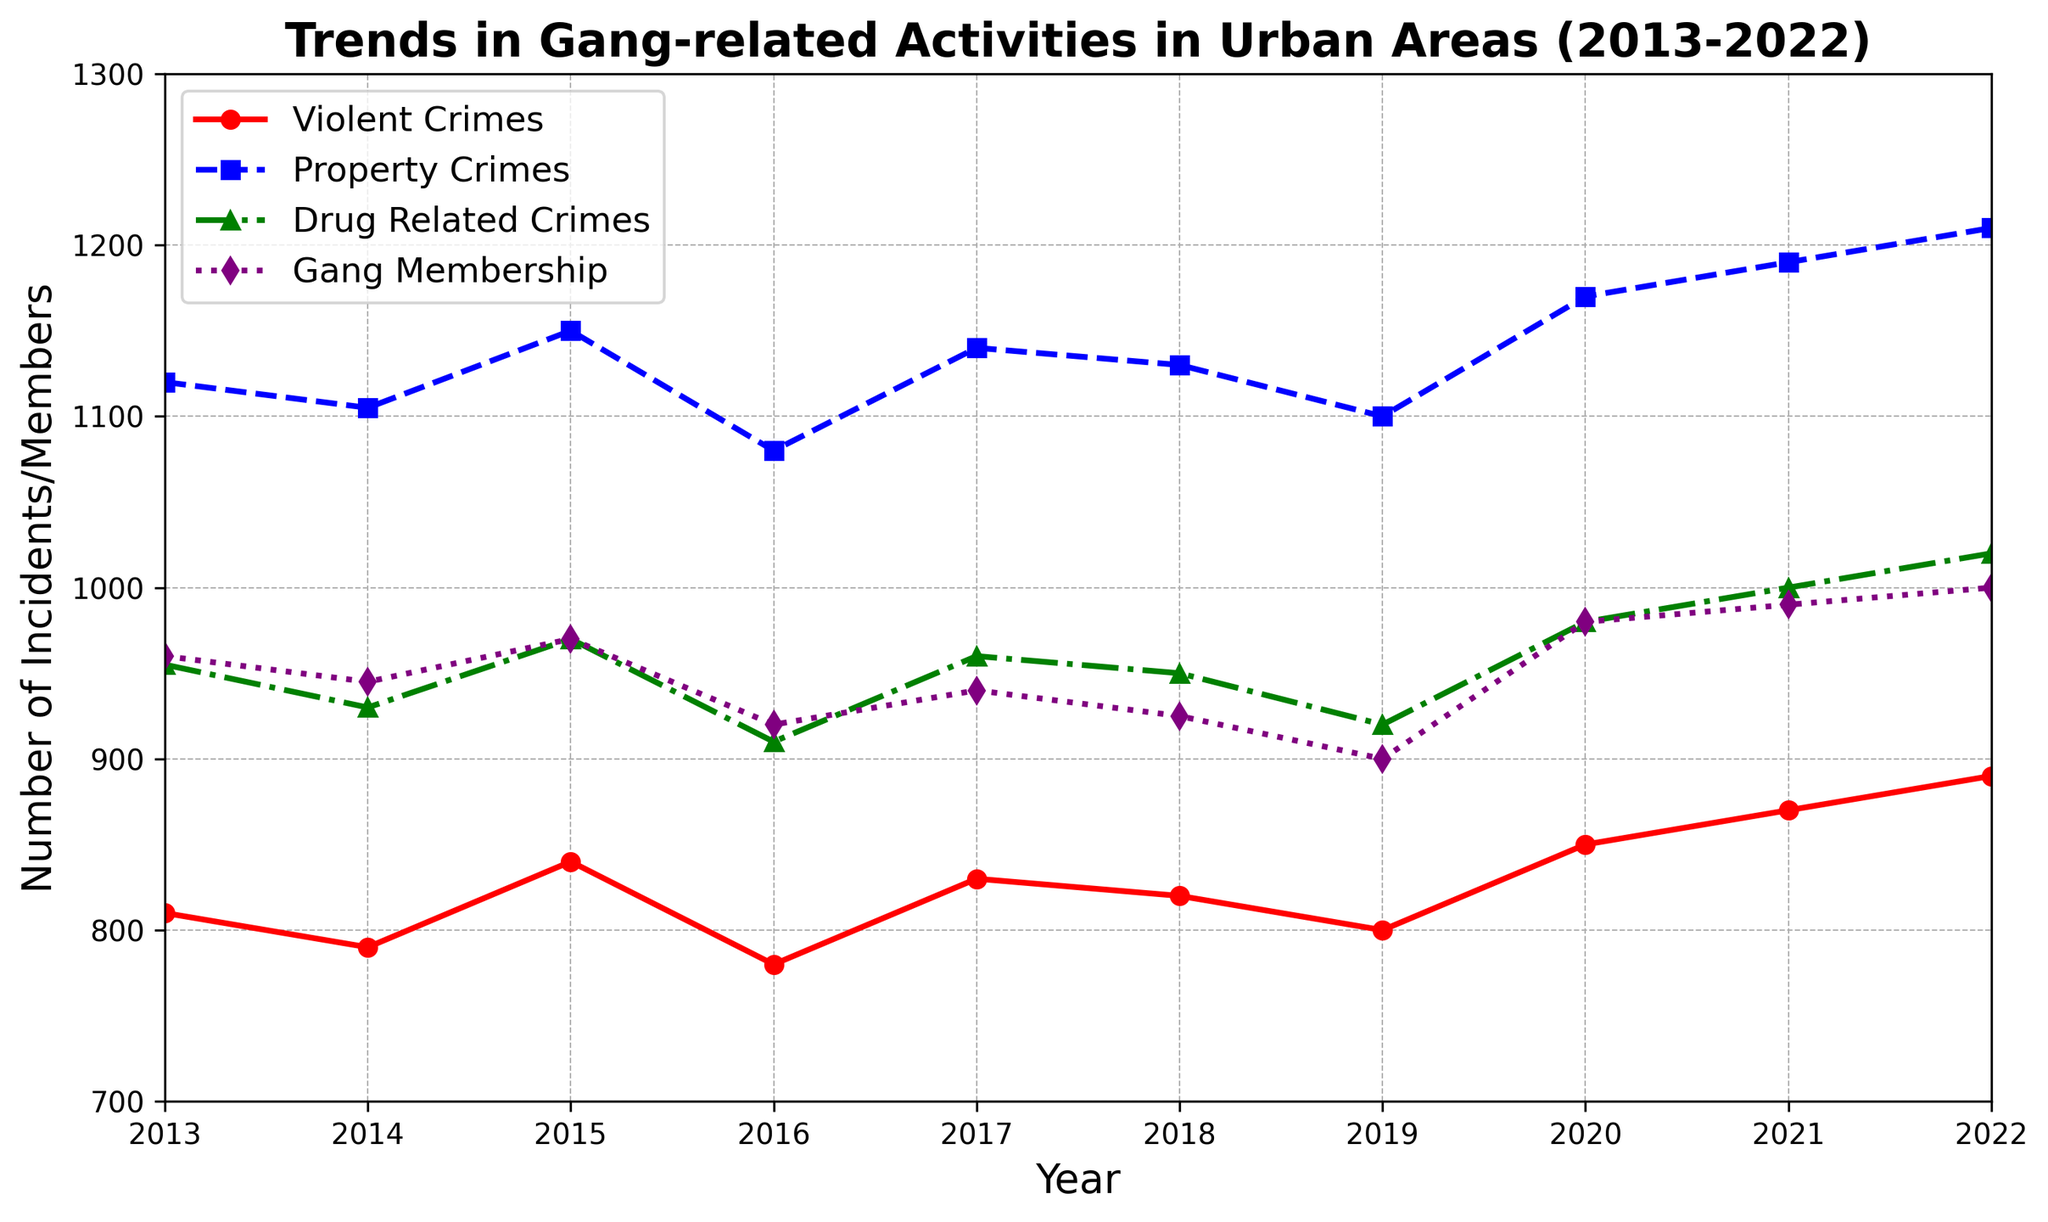Which year had the highest number of violent crimes? The red line representing violent crimes reaches its highest point in the year 2022.
Answer: 2022 How many more drug-related crimes were there in 2022 compared to 2013? To find this, subtract the number of drug-related crimes in 2013 (955) from the number in 2022 (1020): 1020 - 955 = 65.
Answer: 65 What is the trend in gang membership from 2013 to 2022? The purple line, representing gang membership, shows a slight overall increase from 960 to a peak of 1000 in 2021 and 2022.
Answer: Slight increase Between which consecutive years did property crimes see the largest increase? The blue line for property crimes shows the largest increase between 2019 and 2020, from 1100 to 1170.
Answer: 2019 to 2020 What is the difference between the number of violent crimes and drug-related crimes in 2021? In 2021, the number of violent crimes is 870, and drug-related crimes are 1000. The difference is 1000 - 870 = 130.
Answer: 130 What colors represent each type of crime and gang membership on the plot? Violent Crimes are red, Property Crimes are blue, Drug-Related Crimes are green, and Gang Membership is purple.
Answer: Red, Blue, Green, Purple What is the average number of property crimes over the decade? Sum the property crimes for each year and divide by the number of years. The sum is 1120 + 1105 + 1150 + 1080 + 1140 + 1130 + 1100 + 1170 + 1190 + 1210 = 11495. The average is 11495 / 10 = 1149.5.
Answer: 1149.5 Which type of crime has the most noticeable increase from 2013 to 2022? The green line for drug-related crimes increases from 955 to 1020, which is more noticeable compared to the other types of crimes.
Answer: Drug-related crimes 